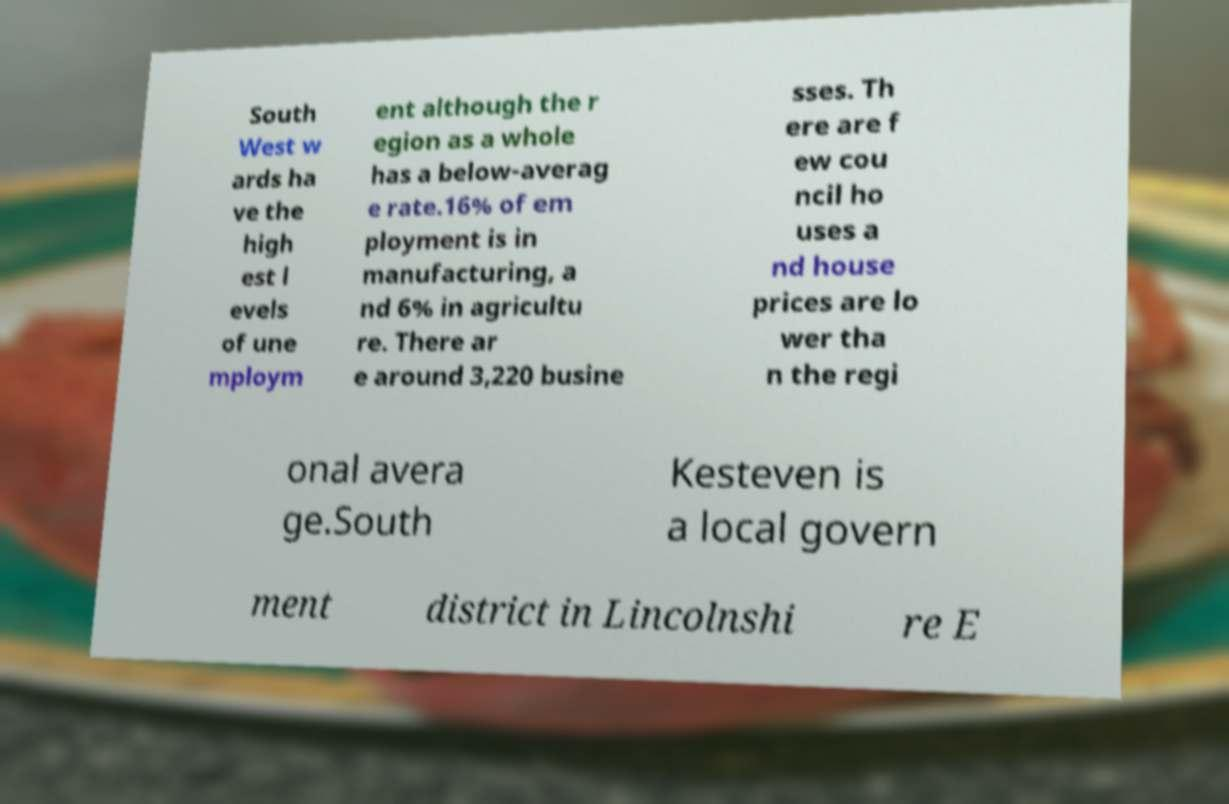What messages or text are displayed in this image? I need them in a readable, typed format. South West w ards ha ve the high est l evels of une mploym ent although the r egion as a whole has a below-averag e rate.16% of em ployment is in manufacturing, a nd 6% in agricultu re. There ar e around 3,220 busine sses. Th ere are f ew cou ncil ho uses a nd house prices are lo wer tha n the regi onal avera ge.South Kesteven is a local govern ment district in Lincolnshi re E 